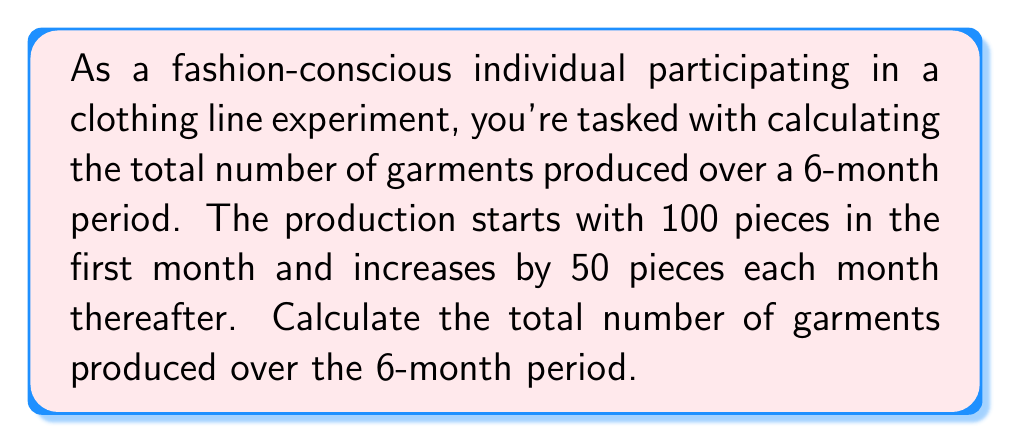Provide a solution to this math problem. Let's approach this step-by-step using the arithmetic sequence formula:

1) First, identify the components of the arithmetic sequence:
   - $a_1 = 100$ (first term: 100 pieces in the first month)
   - $d = 50$ (common difference: increase of 50 pieces each month)
   - $n = 6$ (number of terms: 6 months)

2) The formula for the sum of an arithmetic sequence is:

   $$S_n = \frac{n}{2}(a_1 + a_n)$$

   where $a_n$ is the last term of the sequence.

3) To find $a_n$, use the arithmetic sequence formula:
   
   $$a_n = a_1 + (n-1)d$$
   $$a_6 = 100 + (6-1)50 = 100 + 250 = 350$$

4) Now, substitute the values into the sum formula:

   $$S_6 = \frac{6}{2}(100 + 350)$$
   $$S_6 = 3(450)$$
   $$S_6 = 1350$$

Therefore, the total number of garments produced over the 6-month period is 1,350 pieces.
Answer: 1,350 garments 